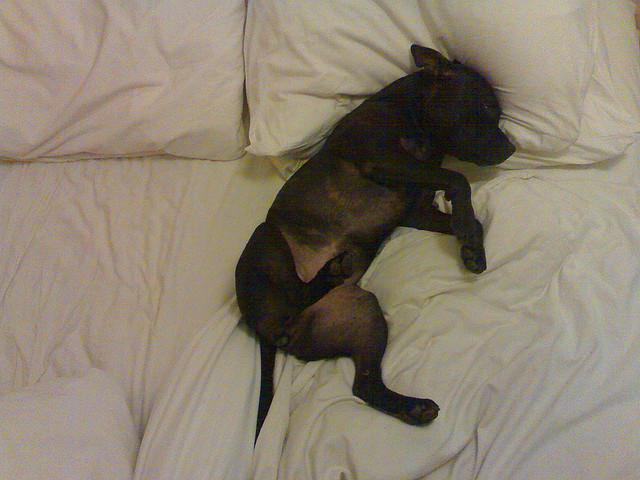What color is this dog's hair?
Quick response, please. Black. What is the dog's tail pointing at?
Keep it brief. Bed. Is the dog asleep?
Short answer required. Yes. What is the dog lying on?
Short answer required. Bed. 